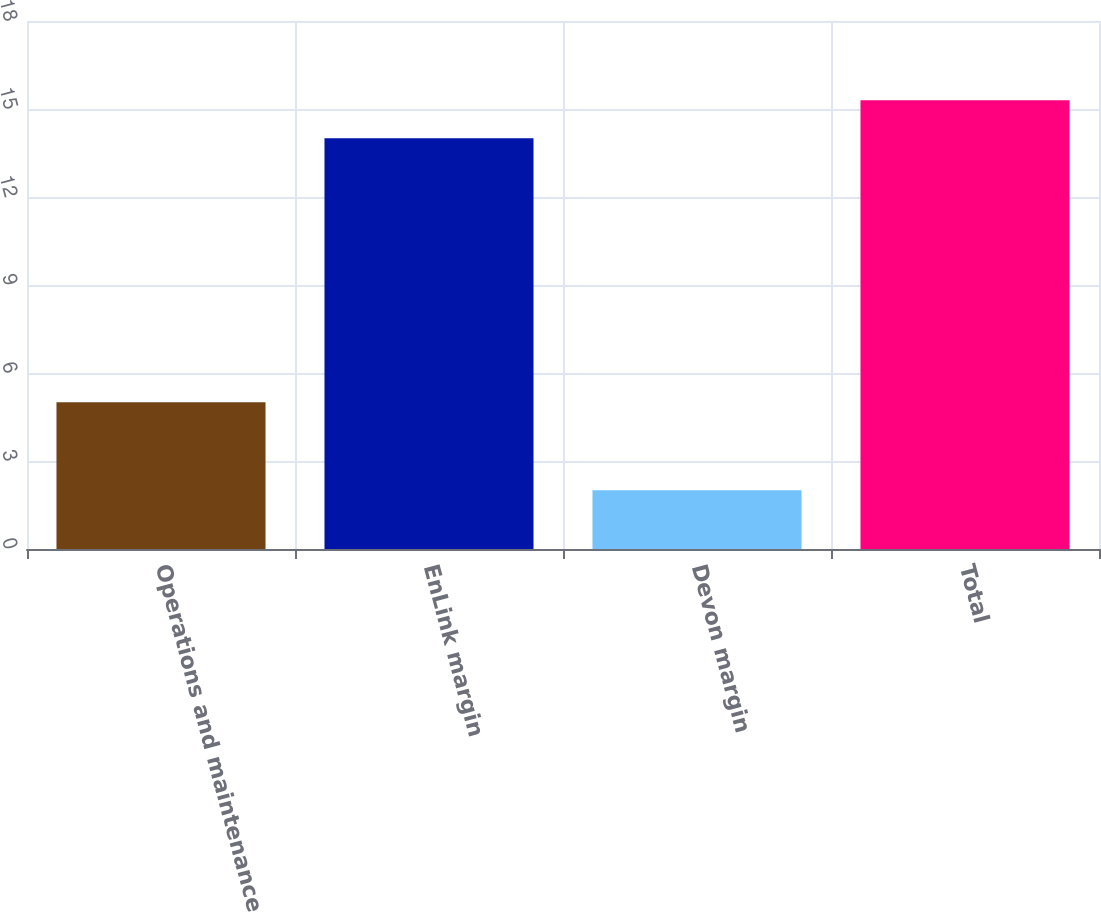<chart> <loc_0><loc_0><loc_500><loc_500><bar_chart><fcel>Operations and maintenance<fcel>EnLink margin<fcel>Devon margin<fcel>Total<nl><fcel>5<fcel>14<fcel>2<fcel>15.3<nl></chart> 